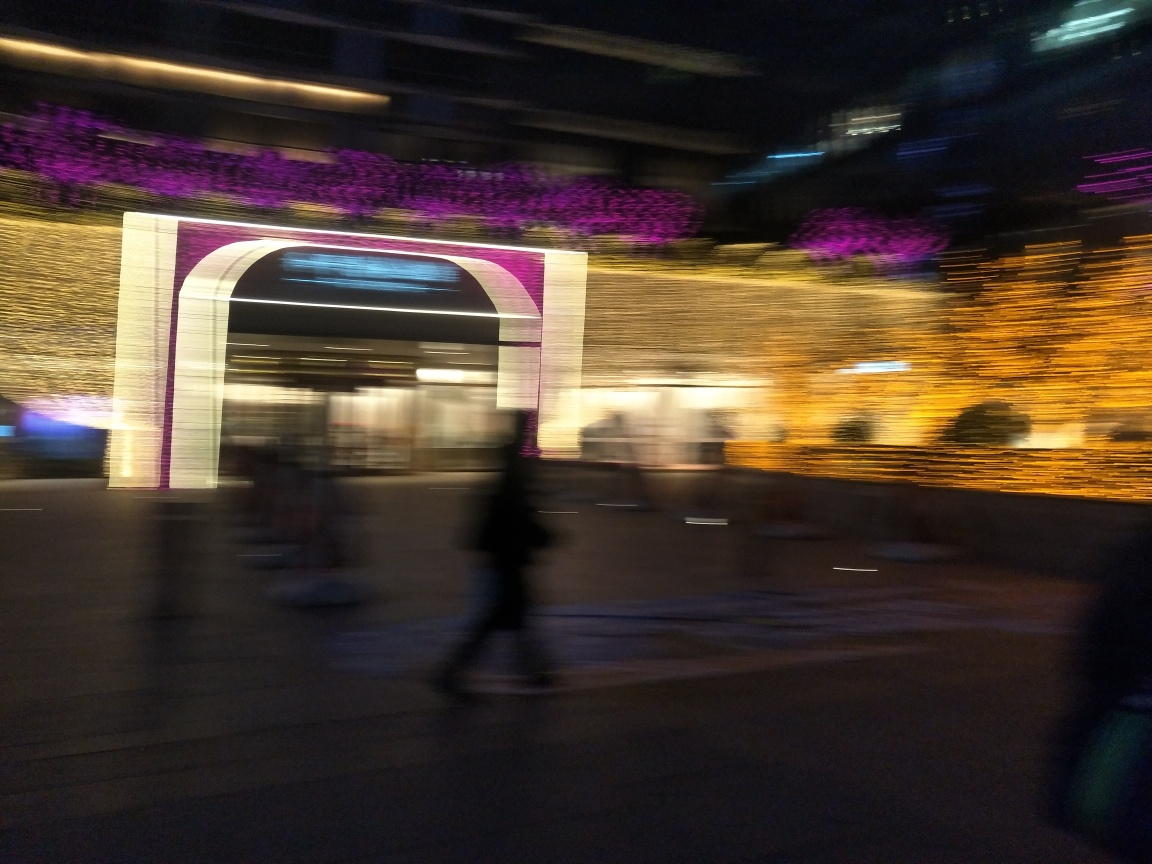Is the overall sharpness of this image high? The sharpness of the image is indeed quite low. The scene is blurred due to motion, indicated by streaking lights and the lack of clear details in the moving subjects, suggesting a long exposure or movement during capture. 